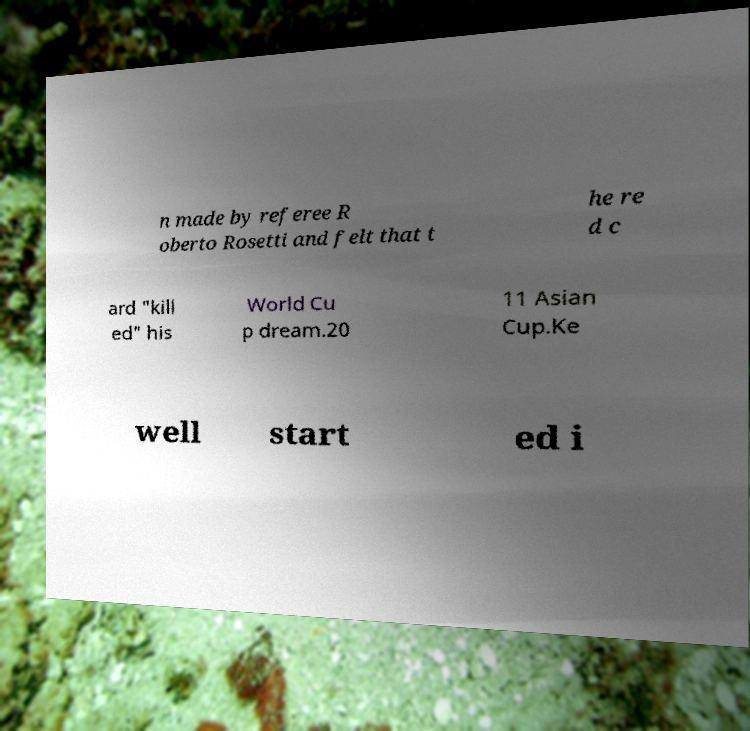For documentation purposes, I need the text within this image transcribed. Could you provide that? n made by referee R oberto Rosetti and felt that t he re d c ard "kill ed" his World Cu p dream.20 11 Asian Cup.Ke well start ed i 